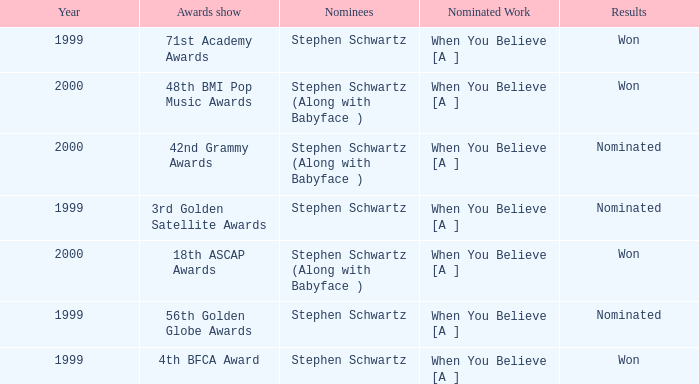Which Nominated Work won in 2000? When You Believe [A ], When You Believe [A ]. 